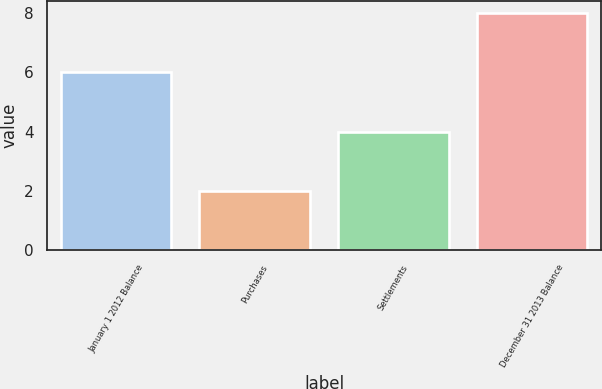Convert chart. <chart><loc_0><loc_0><loc_500><loc_500><bar_chart><fcel>January 1 2012 Balance<fcel>Purchases<fcel>Settlements<fcel>December 31 2013 Balance<nl><fcel>6<fcel>2<fcel>4<fcel>8<nl></chart> 